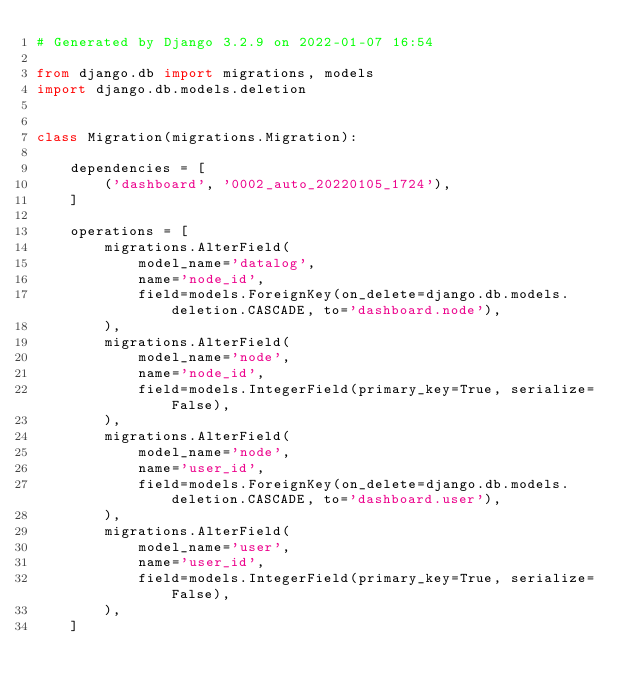<code> <loc_0><loc_0><loc_500><loc_500><_Python_># Generated by Django 3.2.9 on 2022-01-07 16:54

from django.db import migrations, models
import django.db.models.deletion


class Migration(migrations.Migration):

    dependencies = [
        ('dashboard', '0002_auto_20220105_1724'),
    ]

    operations = [
        migrations.AlterField(
            model_name='datalog',
            name='node_id',
            field=models.ForeignKey(on_delete=django.db.models.deletion.CASCADE, to='dashboard.node'),
        ),
        migrations.AlterField(
            model_name='node',
            name='node_id',
            field=models.IntegerField(primary_key=True, serialize=False),
        ),
        migrations.AlterField(
            model_name='node',
            name='user_id',
            field=models.ForeignKey(on_delete=django.db.models.deletion.CASCADE, to='dashboard.user'),
        ),
        migrations.AlterField(
            model_name='user',
            name='user_id',
            field=models.IntegerField(primary_key=True, serialize=False),
        ),
    ]
</code> 